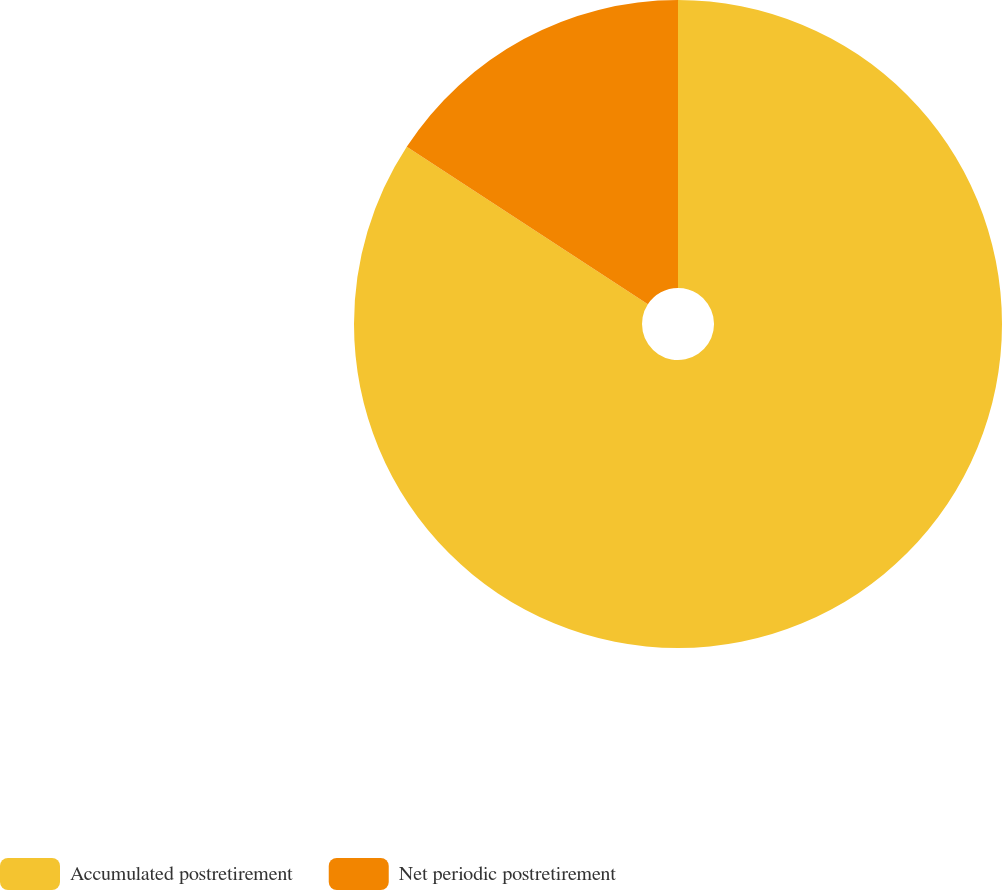<chart> <loc_0><loc_0><loc_500><loc_500><pie_chart><fcel>Accumulated postretirement<fcel>Net periodic postretirement<nl><fcel>84.21%<fcel>15.79%<nl></chart> 